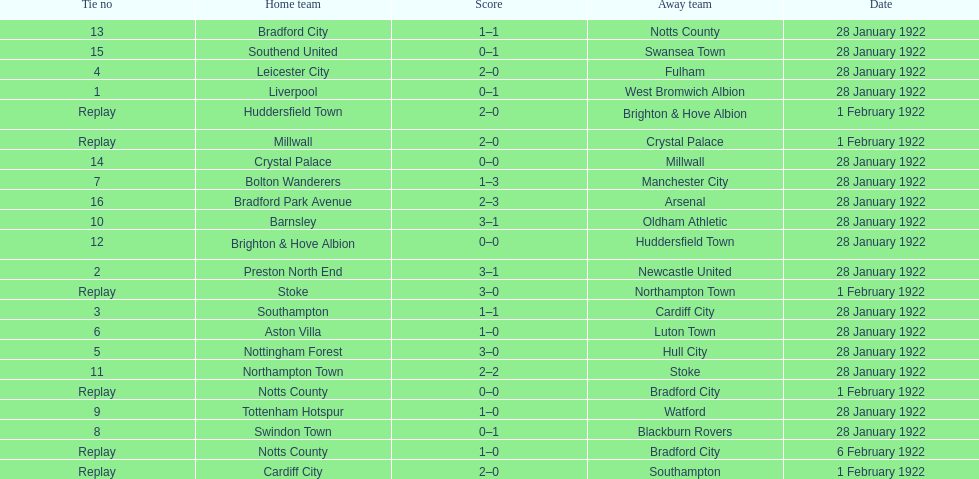How many games had no points scored? 3. 